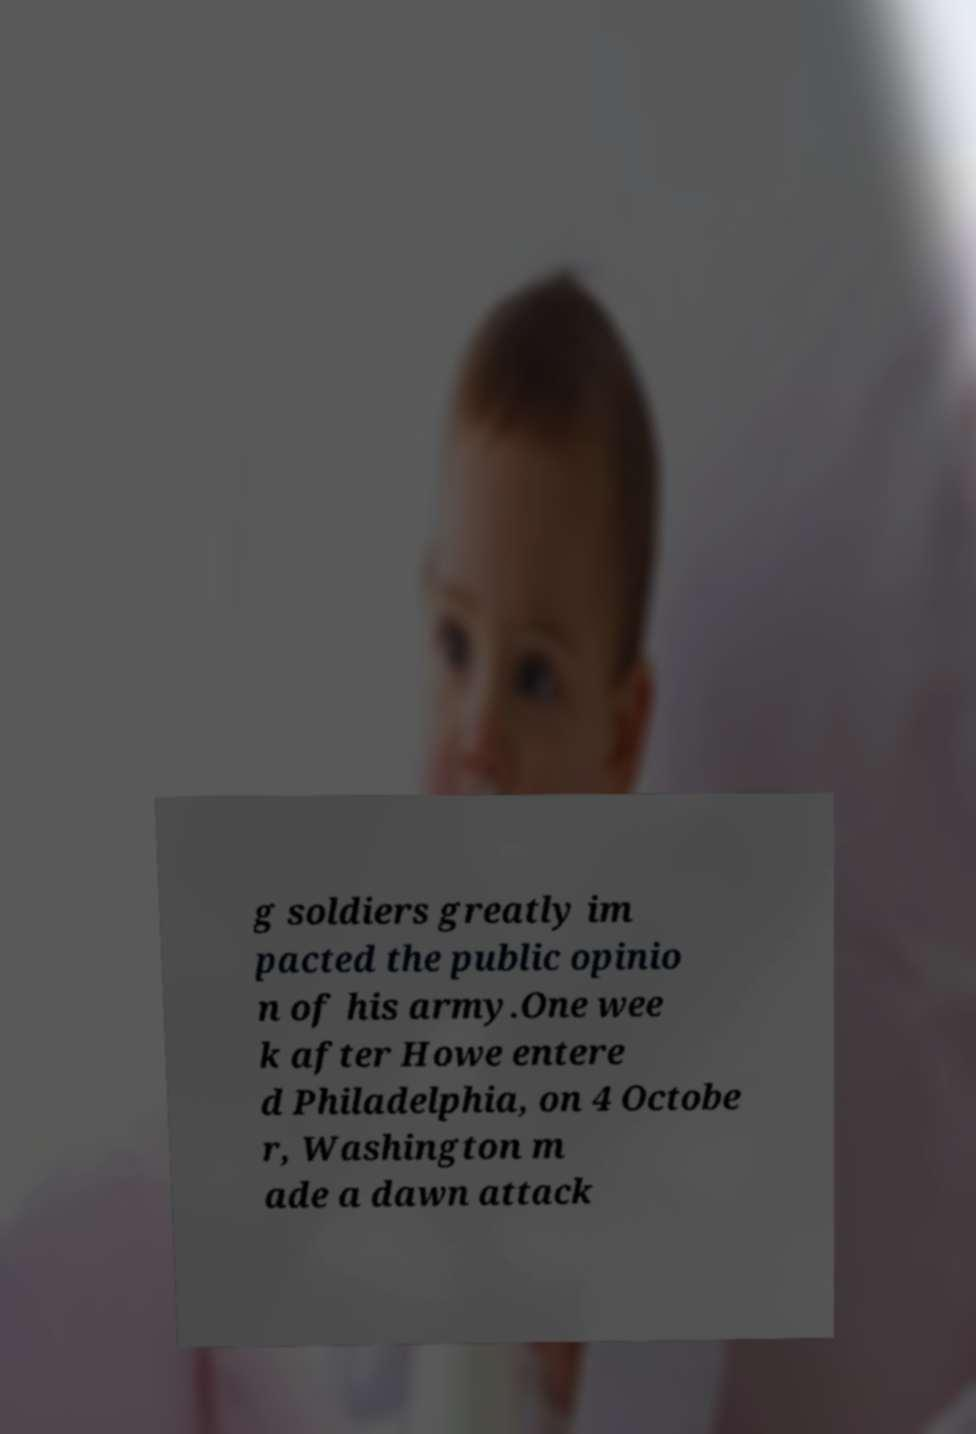Could you extract and type out the text from this image? g soldiers greatly im pacted the public opinio n of his army.One wee k after Howe entere d Philadelphia, on 4 Octobe r, Washington m ade a dawn attack 